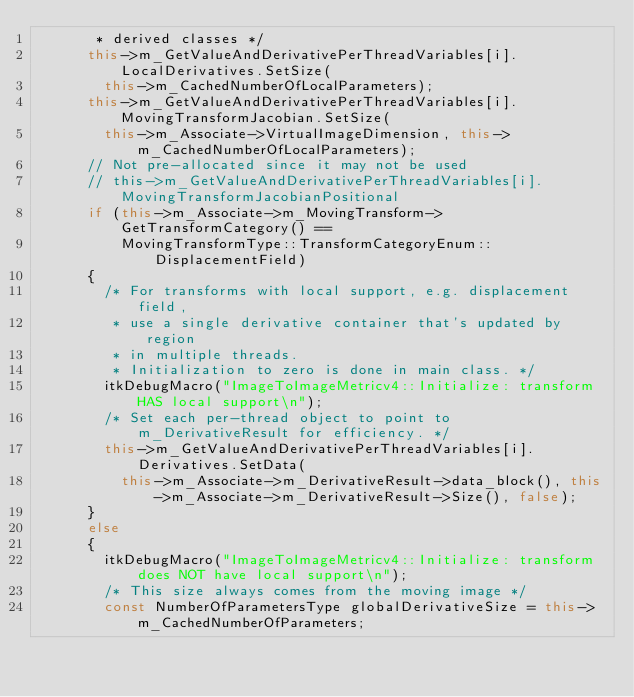<code> <loc_0><loc_0><loc_500><loc_500><_C++_>       * derived classes */
      this->m_GetValueAndDerivativePerThreadVariables[i].LocalDerivatives.SetSize(
        this->m_CachedNumberOfLocalParameters);
      this->m_GetValueAndDerivativePerThreadVariables[i].MovingTransformJacobian.SetSize(
        this->m_Associate->VirtualImageDimension, this->m_CachedNumberOfLocalParameters);
      // Not pre-allocated since it may not be used
      // this->m_GetValueAndDerivativePerThreadVariables[i].MovingTransformJacobianPositional
      if (this->m_Associate->m_MovingTransform->GetTransformCategory() ==
          MovingTransformType::TransformCategoryEnum::DisplacementField)
      {
        /* For transforms with local support, e.g. displacement field,
         * use a single derivative container that's updated by region
         * in multiple threads.
         * Initialization to zero is done in main class. */
        itkDebugMacro("ImageToImageMetricv4::Initialize: transform HAS local support\n");
        /* Set each per-thread object to point to m_DerivativeResult for efficiency. */
        this->m_GetValueAndDerivativePerThreadVariables[i].Derivatives.SetData(
          this->m_Associate->m_DerivativeResult->data_block(), this->m_Associate->m_DerivativeResult->Size(), false);
      }
      else
      {
        itkDebugMacro("ImageToImageMetricv4::Initialize: transform does NOT have local support\n");
        /* This size always comes from the moving image */
        const NumberOfParametersType globalDerivativeSize = this->m_CachedNumberOfParameters;</code> 